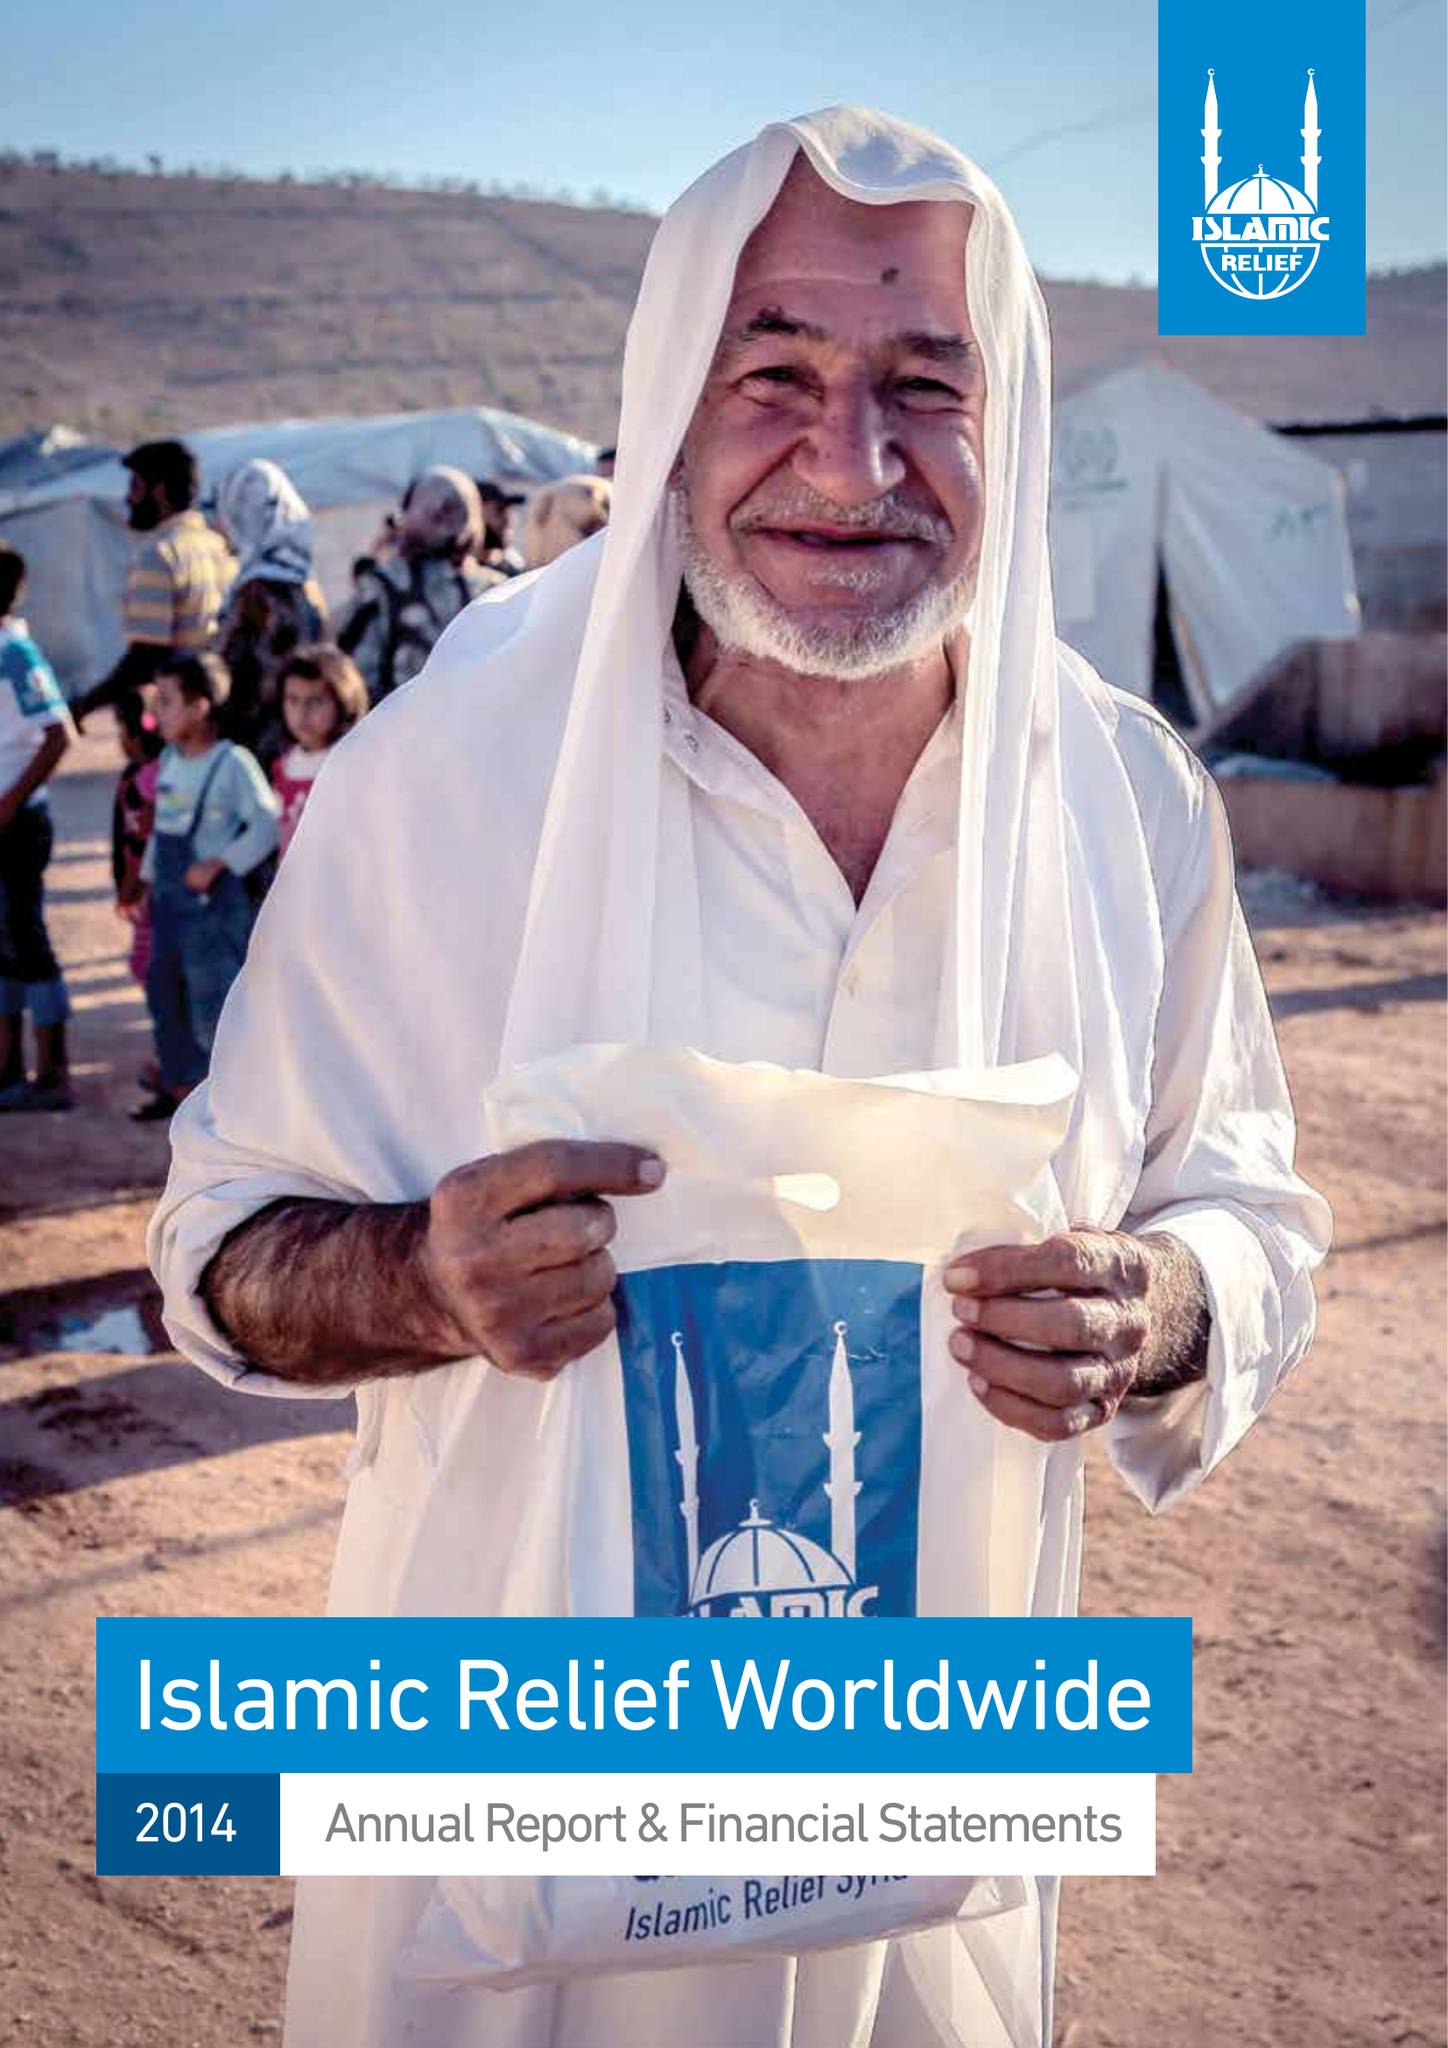What is the value for the charity_number?
Answer the question using a single word or phrase. 328158 